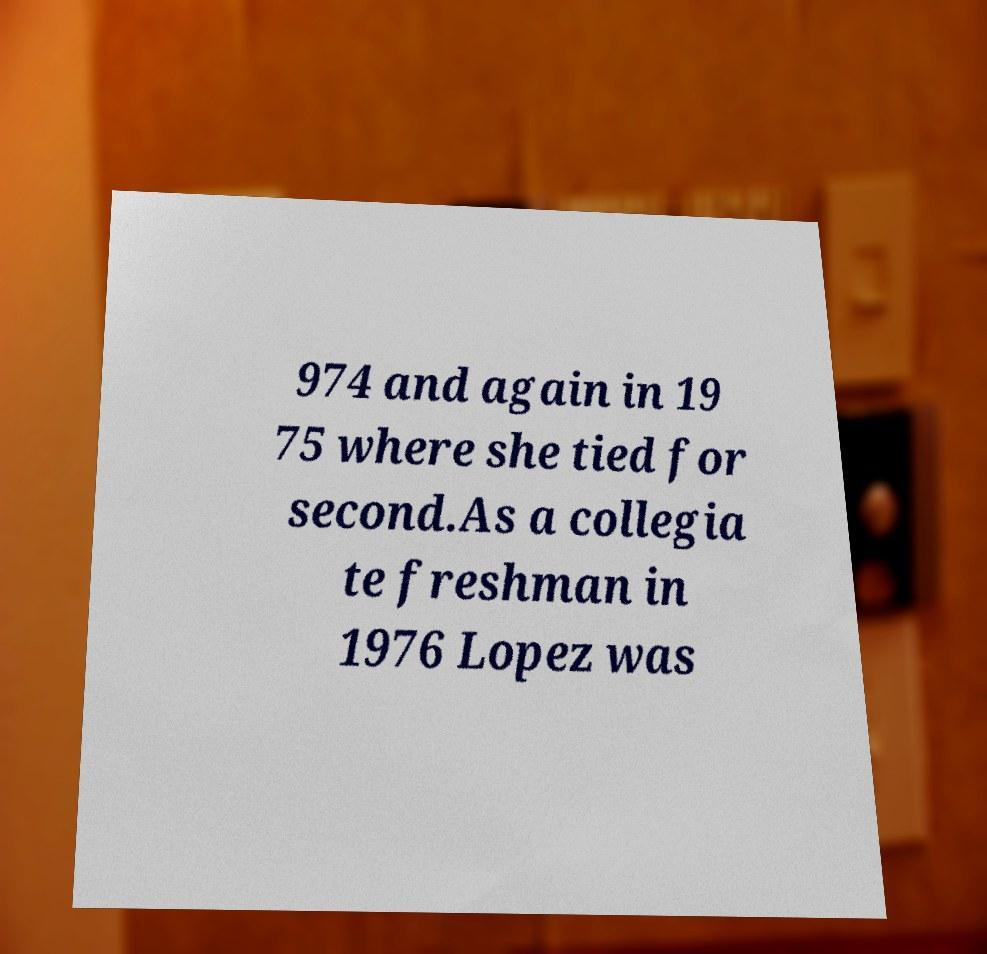For documentation purposes, I need the text within this image transcribed. Could you provide that? 974 and again in 19 75 where she tied for second.As a collegia te freshman in 1976 Lopez was 